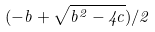<formula> <loc_0><loc_0><loc_500><loc_500>( - b + \sqrt { b ^ { 2 } - 4 c } ) / 2</formula> 